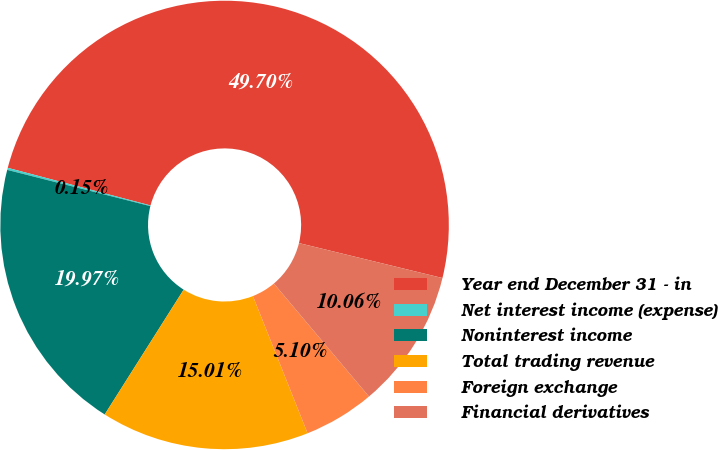<chart> <loc_0><loc_0><loc_500><loc_500><pie_chart><fcel>Year end December 31 - in<fcel>Net interest income (expense)<fcel>Noninterest income<fcel>Total trading revenue<fcel>Foreign exchange<fcel>Financial derivatives<nl><fcel>49.7%<fcel>0.15%<fcel>19.97%<fcel>15.01%<fcel>5.1%<fcel>10.06%<nl></chart> 